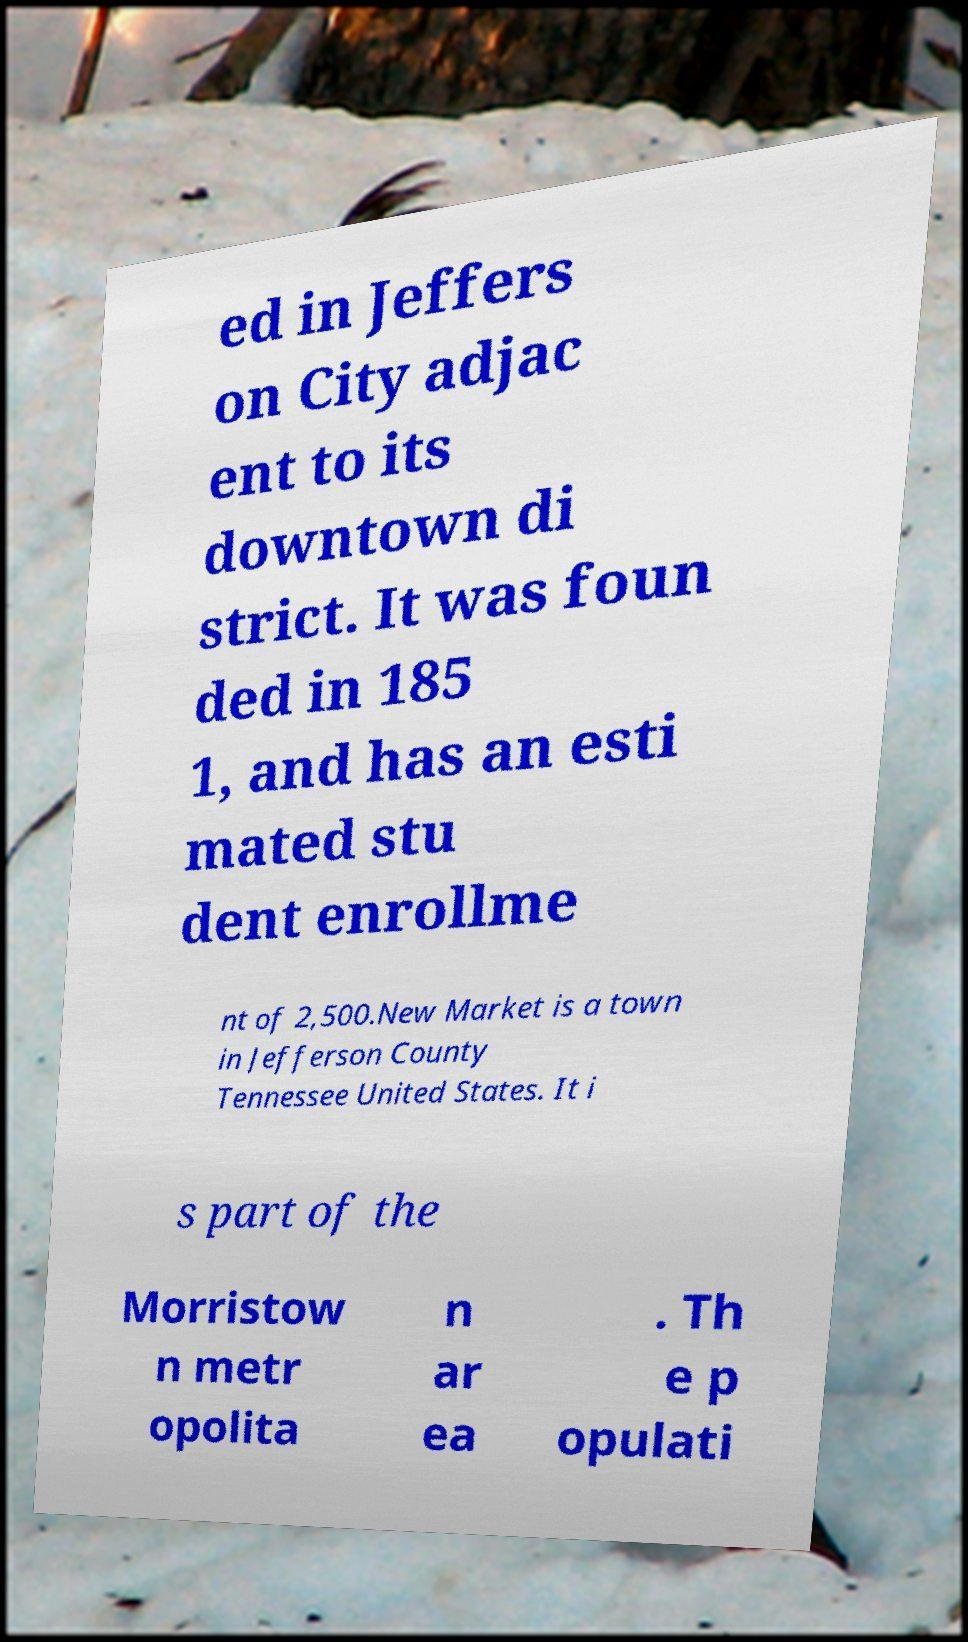Could you extract and type out the text from this image? ed in Jeffers on City adjac ent to its downtown di strict. It was foun ded in 185 1, and has an esti mated stu dent enrollme nt of 2,500.New Market is a town in Jefferson County Tennessee United States. It i s part of the Morristow n metr opolita n ar ea . Th e p opulati 